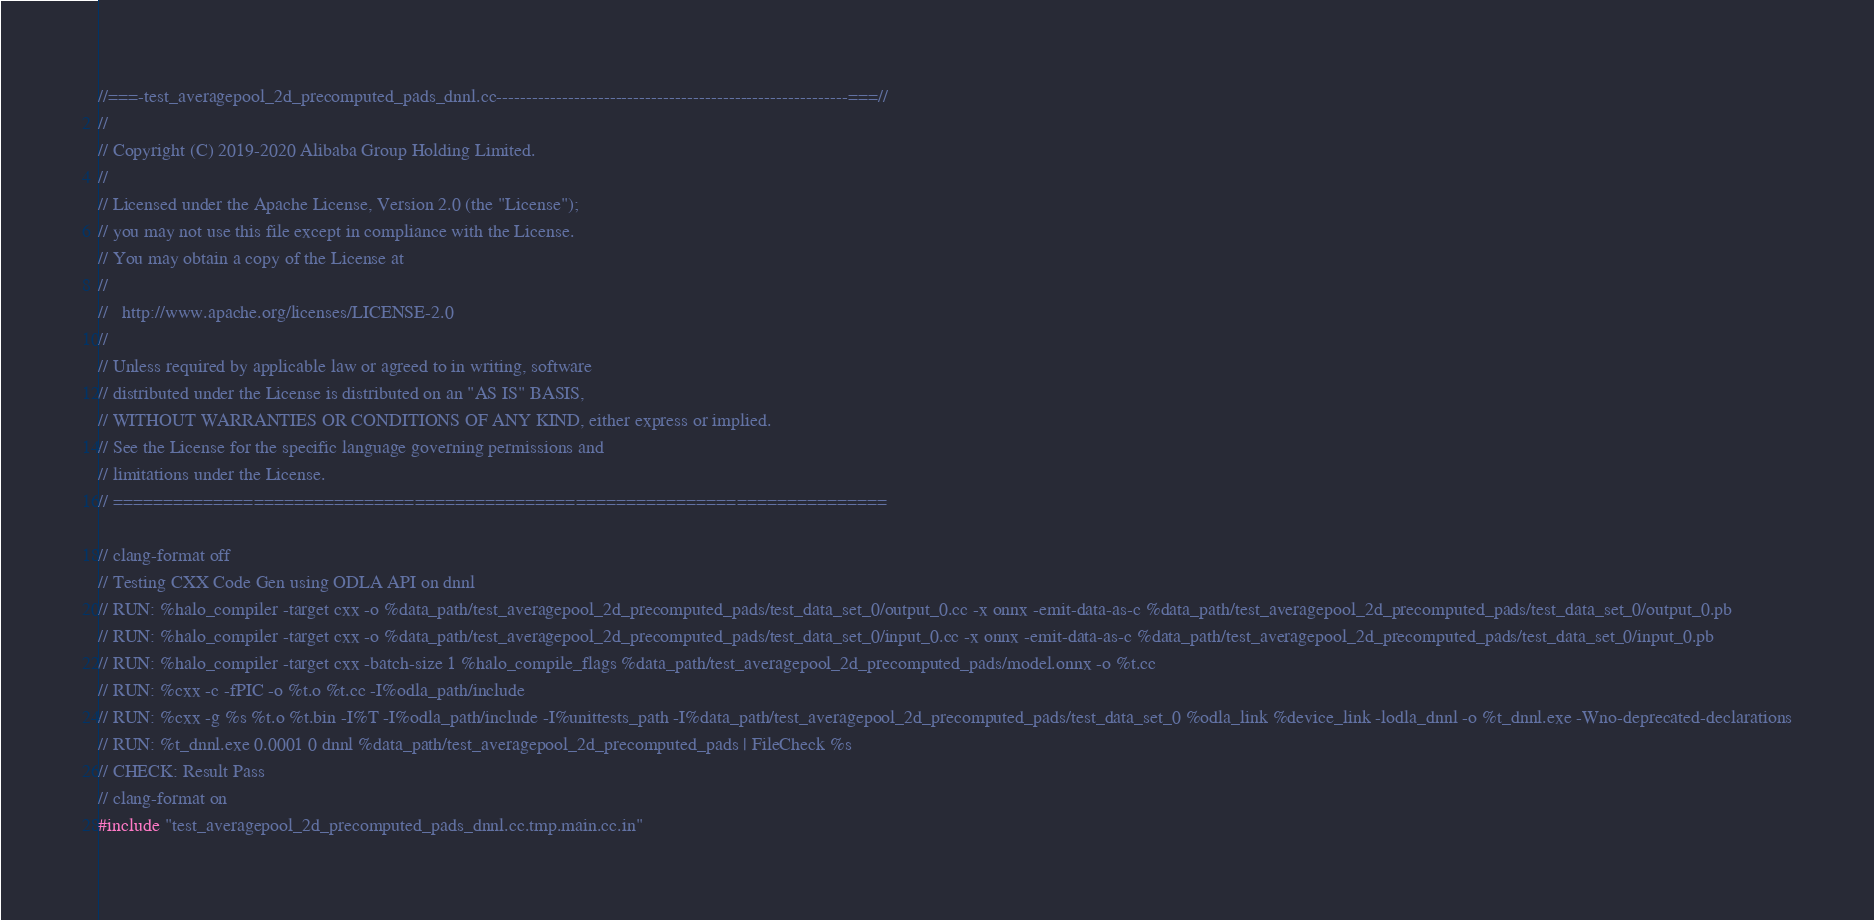<code> <loc_0><loc_0><loc_500><loc_500><_C++_>//===-test_averagepool_2d_precomputed_pads_dnnl.cc-----------------------------------------------------------===//
//
// Copyright (C) 2019-2020 Alibaba Group Holding Limited.
//
// Licensed under the Apache License, Version 2.0 (the "License");
// you may not use this file except in compliance with the License.
// You may obtain a copy of the License at
//
//   http://www.apache.org/licenses/LICENSE-2.0
//
// Unless required by applicable law or agreed to in writing, software
// distributed under the License is distributed on an "AS IS" BASIS,
// WITHOUT WARRANTIES OR CONDITIONS OF ANY KIND, either express or implied.
// See the License for the specific language governing permissions and
// limitations under the License.
// =============================================================================

// clang-format off
// Testing CXX Code Gen using ODLA API on dnnl
// RUN: %halo_compiler -target cxx -o %data_path/test_averagepool_2d_precomputed_pads/test_data_set_0/output_0.cc -x onnx -emit-data-as-c %data_path/test_averagepool_2d_precomputed_pads/test_data_set_0/output_0.pb
// RUN: %halo_compiler -target cxx -o %data_path/test_averagepool_2d_precomputed_pads/test_data_set_0/input_0.cc -x onnx -emit-data-as-c %data_path/test_averagepool_2d_precomputed_pads/test_data_set_0/input_0.pb
// RUN: %halo_compiler -target cxx -batch-size 1 %halo_compile_flags %data_path/test_averagepool_2d_precomputed_pads/model.onnx -o %t.cc
// RUN: %cxx -c -fPIC -o %t.o %t.cc -I%odla_path/include
// RUN: %cxx -g %s %t.o %t.bin -I%T -I%odla_path/include -I%unittests_path -I%data_path/test_averagepool_2d_precomputed_pads/test_data_set_0 %odla_link %device_link -lodla_dnnl -o %t_dnnl.exe -Wno-deprecated-declarations
// RUN: %t_dnnl.exe 0.0001 0 dnnl %data_path/test_averagepool_2d_precomputed_pads | FileCheck %s
// CHECK: Result Pass
// clang-format on
#include "test_averagepool_2d_precomputed_pads_dnnl.cc.tmp.main.cc.in"
</code> 